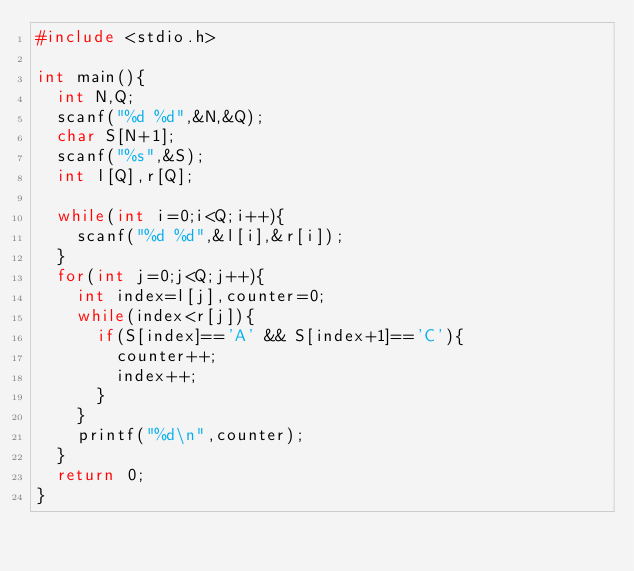<code> <loc_0><loc_0><loc_500><loc_500><_C_>#include <stdio.h>

int main(){
  int N,Q;
  scanf("%d %d",&N,&Q);
  char S[N+1];
  scanf("%s",&S);
  int l[Q],r[Q];

  while(int i=0;i<Q;i++){
    scanf("%d %d",&l[i],&r[i]);
  }
  for(int j=0;j<Q;j++){
    int index=l[j],counter=0;
    while(index<r[j]){
      if(S[index]=='A' && S[index+1]=='C'){
        counter++;
        index++;
      }
    }
    printf("%d\n",counter);
  }
  return 0;
}
</code> 